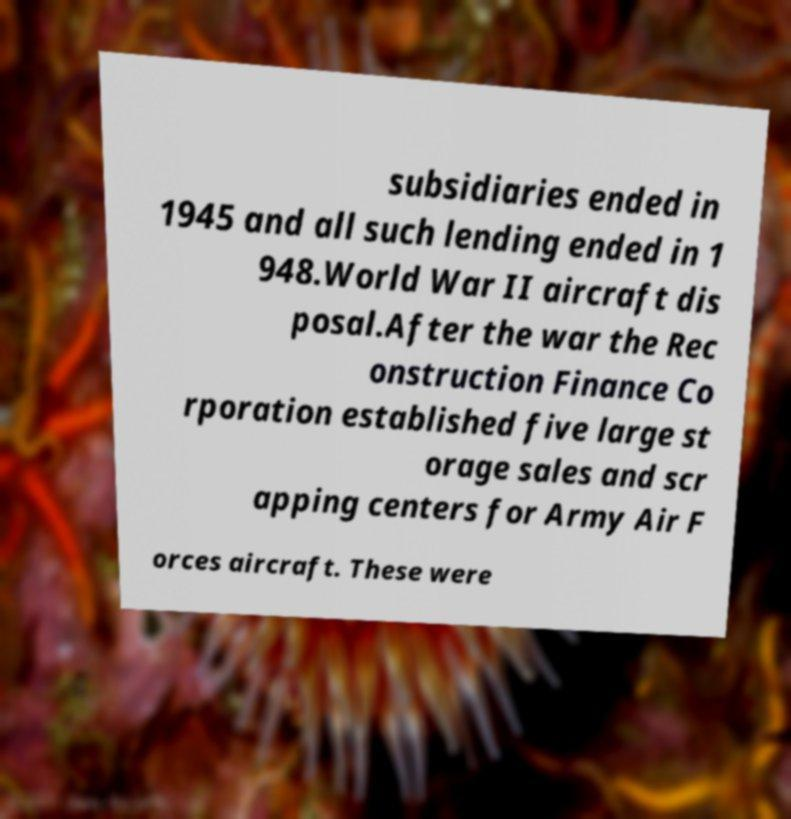Can you accurately transcribe the text from the provided image for me? subsidiaries ended in 1945 and all such lending ended in 1 948.World War II aircraft dis posal.After the war the Rec onstruction Finance Co rporation established five large st orage sales and scr apping centers for Army Air F orces aircraft. These were 